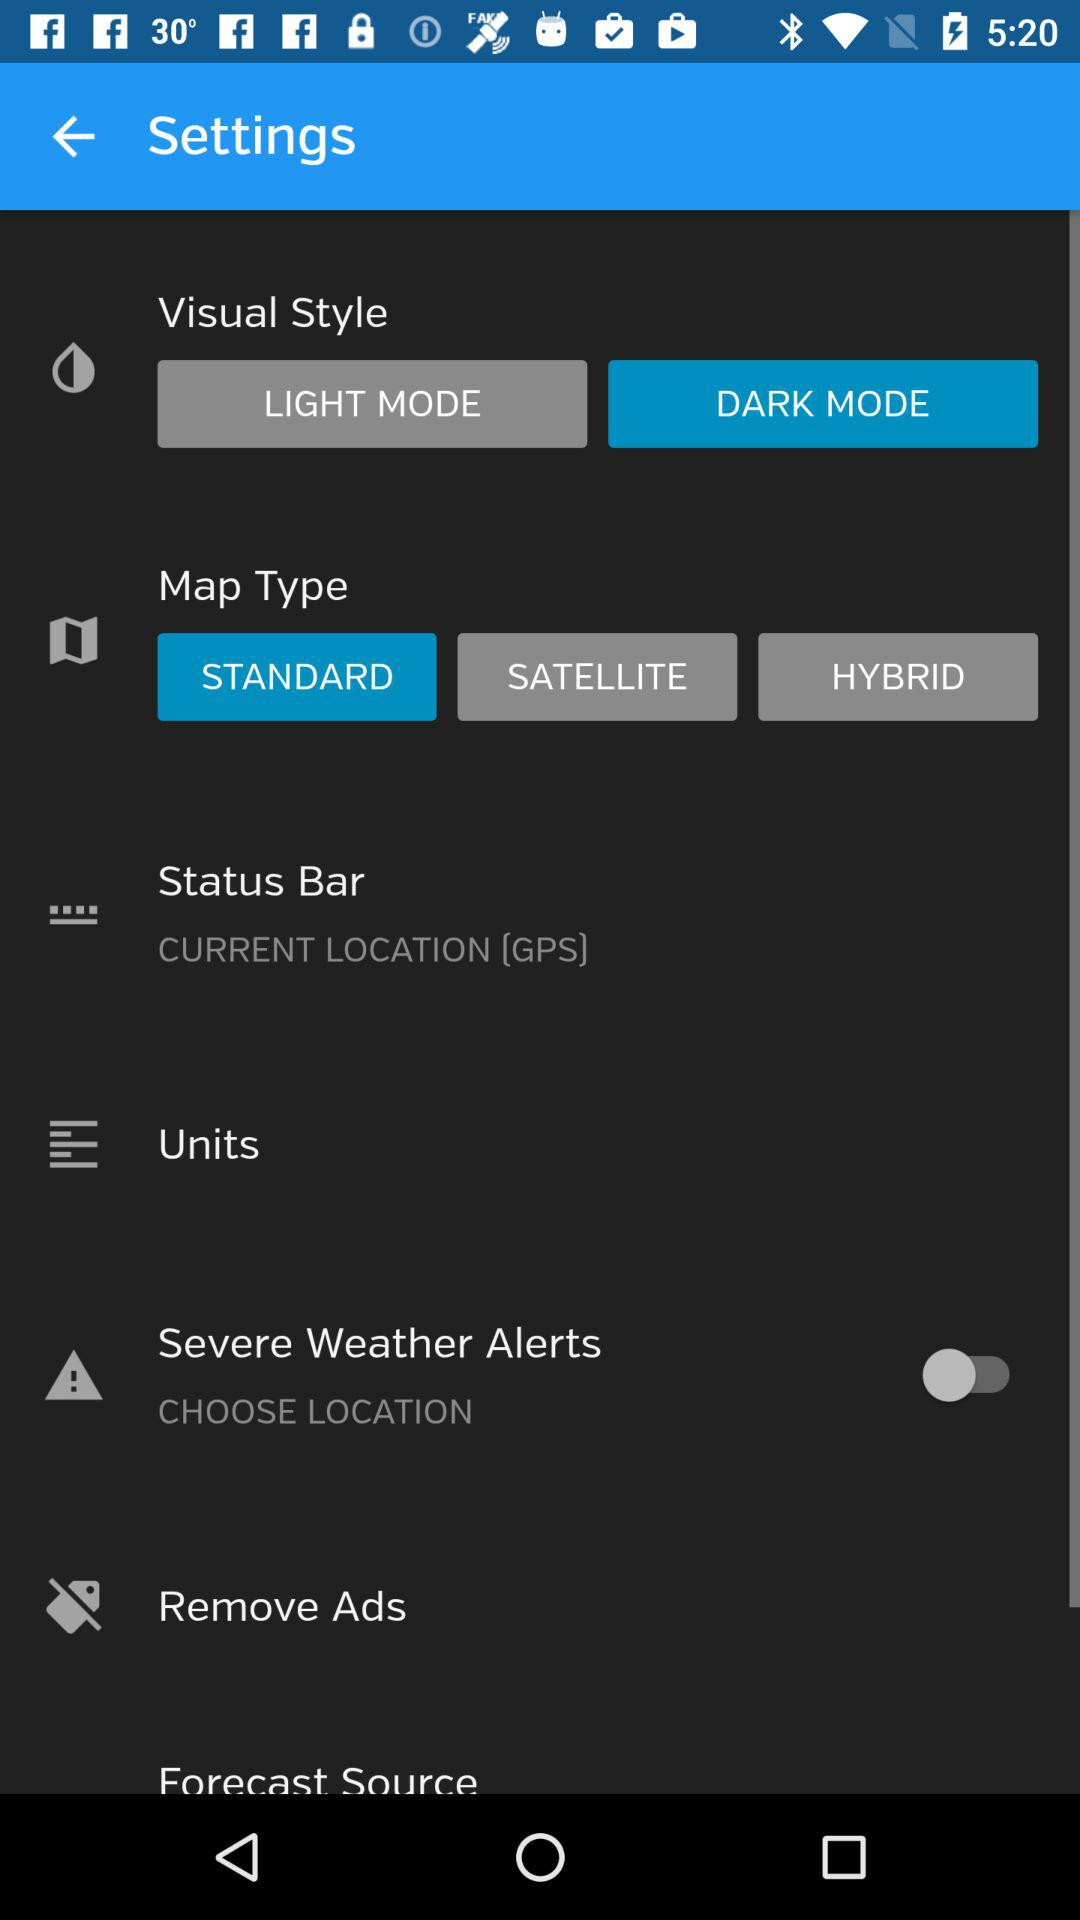What is the status of "Severe Weather Alerts"? The status is "off". 